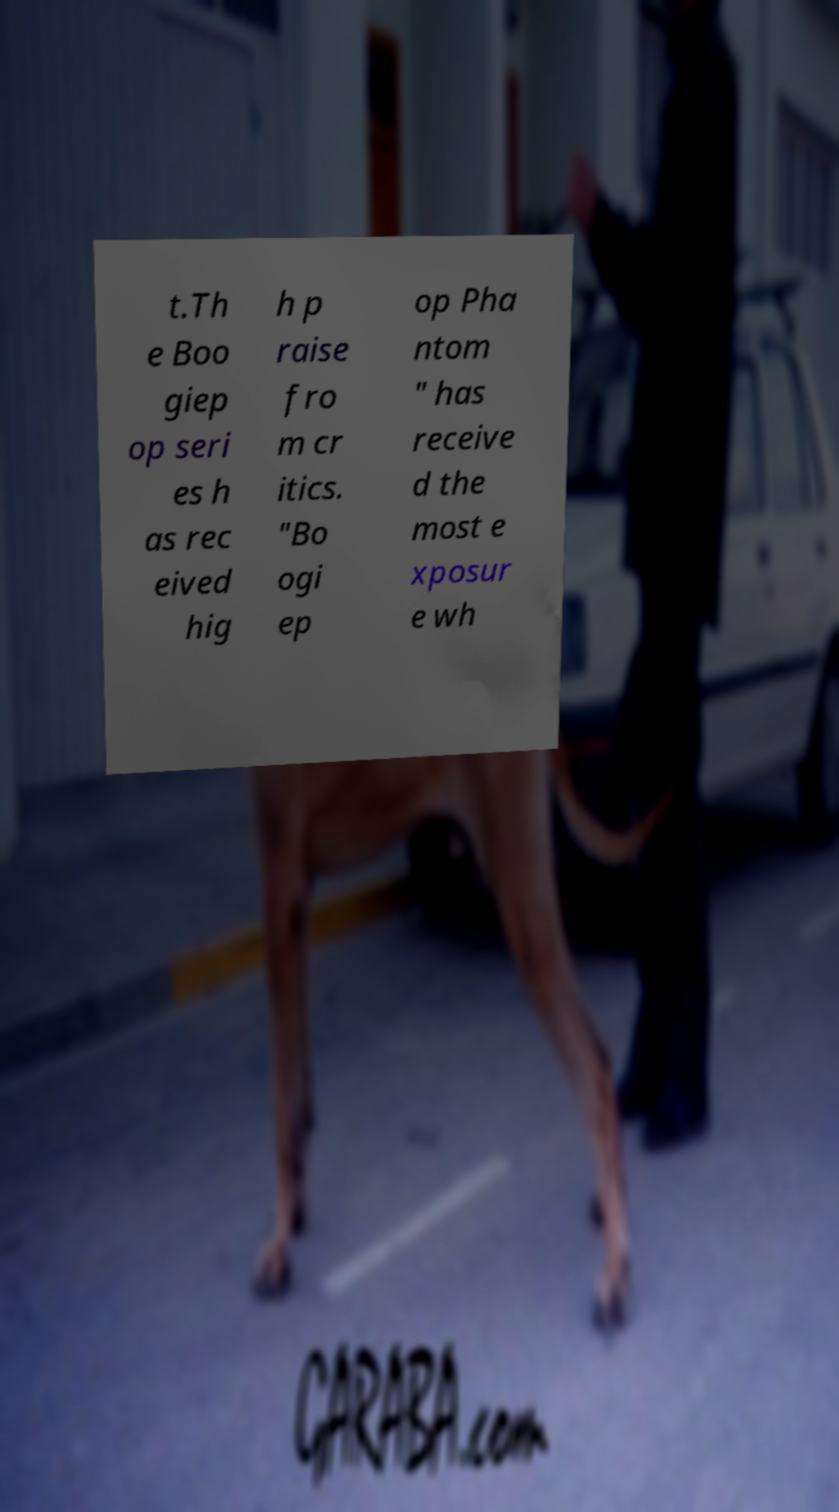Can you accurately transcribe the text from the provided image for me? t.Th e Boo giep op seri es h as rec eived hig h p raise fro m cr itics. "Bo ogi ep op Pha ntom " has receive d the most e xposur e wh 